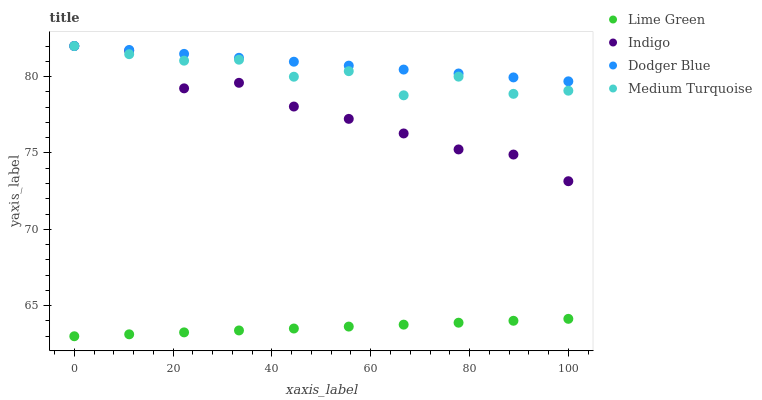Does Lime Green have the minimum area under the curve?
Answer yes or no. Yes. Does Dodger Blue have the maximum area under the curve?
Answer yes or no. Yes. Does Medium Turquoise have the minimum area under the curve?
Answer yes or no. No. Does Medium Turquoise have the maximum area under the curve?
Answer yes or no. No. Is Dodger Blue the smoothest?
Answer yes or no. Yes. Is Medium Turquoise the roughest?
Answer yes or no. Yes. Is Lime Green the smoothest?
Answer yes or no. No. Is Lime Green the roughest?
Answer yes or no. No. Does Lime Green have the lowest value?
Answer yes or no. Yes. Does Medium Turquoise have the lowest value?
Answer yes or no. No. Does Dodger Blue have the highest value?
Answer yes or no. Yes. Does Lime Green have the highest value?
Answer yes or no. No. Is Lime Green less than Dodger Blue?
Answer yes or no. Yes. Is Medium Turquoise greater than Lime Green?
Answer yes or no. Yes. Does Indigo intersect Dodger Blue?
Answer yes or no. Yes. Is Indigo less than Dodger Blue?
Answer yes or no. No. Is Indigo greater than Dodger Blue?
Answer yes or no. No. Does Lime Green intersect Dodger Blue?
Answer yes or no. No. 